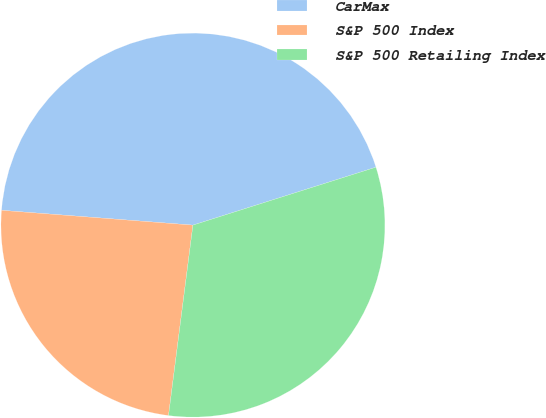Convert chart to OTSL. <chart><loc_0><loc_0><loc_500><loc_500><pie_chart><fcel>CarMax<fcel>S&P 500 Index<fcel>S&P 500 Retailing Index<nl><fcel>43.89%<fcel>24.2%<fcel>31.91%<nl></chart> 